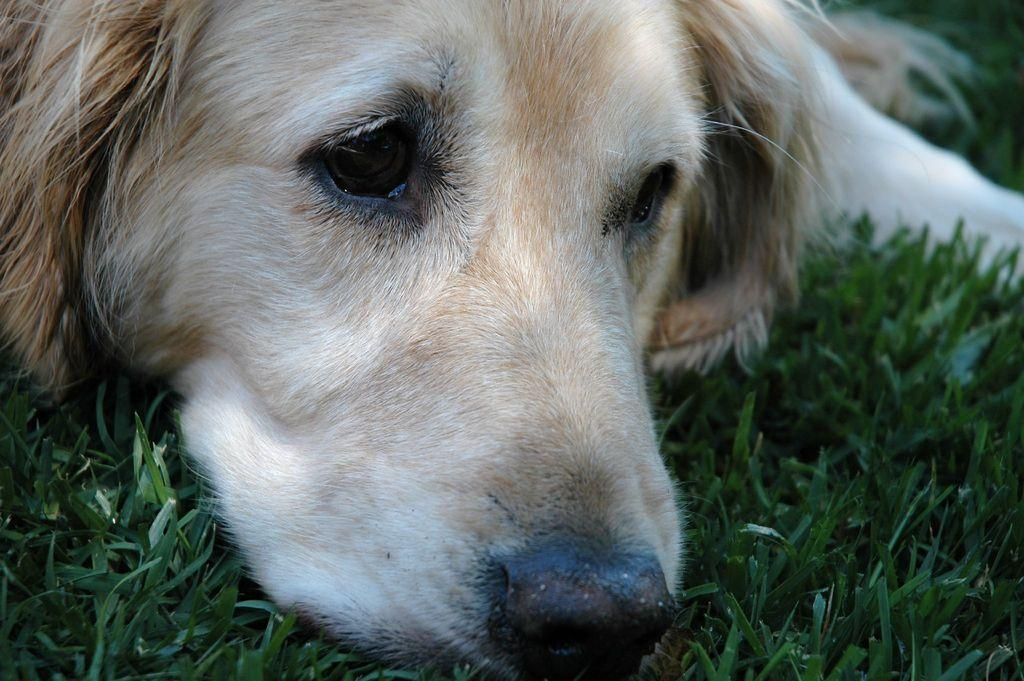What animal can be seen in the image? There is a dog in the image. Where is the dog located? The dog is lying on the grass. What type of spy equipment is the dog using in the image? There is no spy equipment present in the image, and the dog is not depicted as using any. 